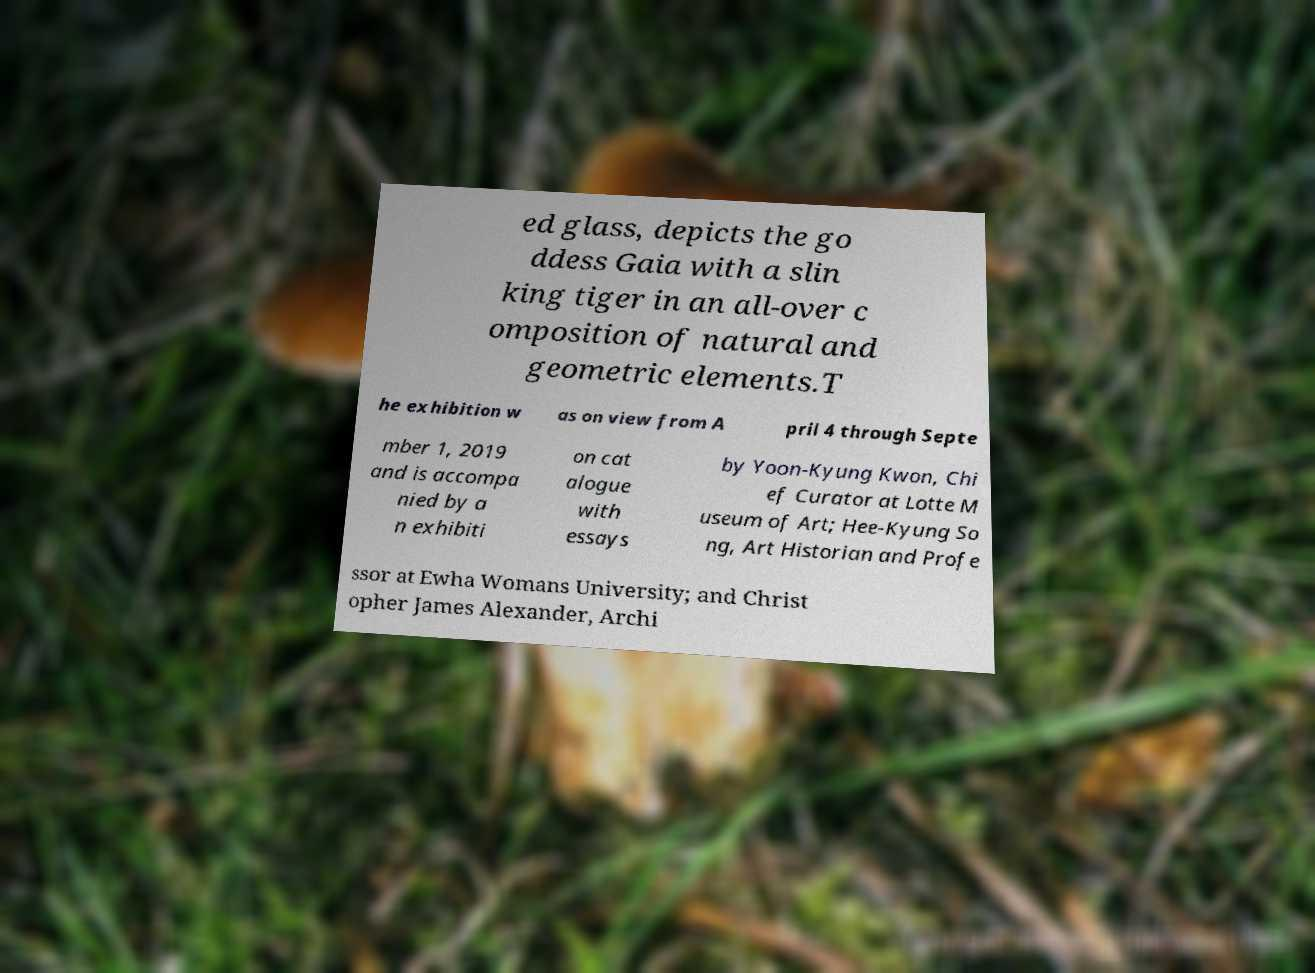Can you accurately transcribe the text from the provided image for me? ed glass, depicts the go ddess Gaia with a slin king tiger in an all-over c omposition of natural and geometric elements.T he exhibition w as on view from A pril 4 through Septe mber 1, 2019 and is accompa nied by a n exhibiti on cat alogue with essays by Yoon-Kyung Kwon, Chi ef Curator at Lotte M useum of Art; Hee-Kyung So ng, Art Historian and Profe ssor at Ewha Womans University; and Christ opher James Alexander, Archi 